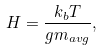<formula> <loc_0><loc_0><loc_500><loc_500>H = \frac { k _ { b } T } { g m _ { a v g } } ,</formula> 